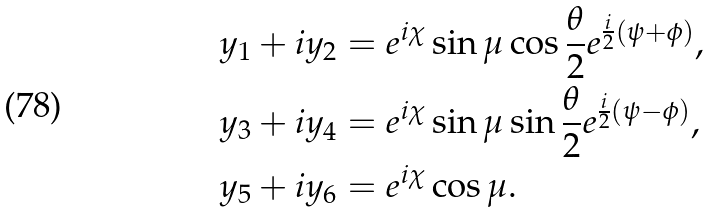Convert formula to latex. <formula><loc_0><loc_0><loc_500><loc_500>y _ { 1 } + i y _ { 2 } & = e ^ { i \chi } \sin { \mu } \cos \frac { \theta } { 2 } e ^ { \frac { i } { 2 } ( \psi + \phi ) } , \\ y _ { 3 } + i y _ { 4 } & = e ^ { i \chi } \sin { \mu } \sin \frac { \theta } { 2 } e ^ { \frac { i } { 2 } ( \psi - \phi ) } , \\ y _ { 5 } + i y _ { 6 } & = e ^ { i \chi } \cos { \mu } .</formula> 